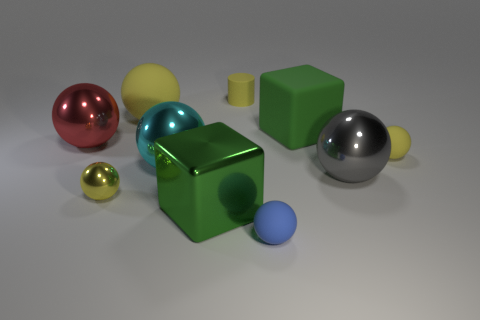Does the small cylinder have the same color as the tiny metallic thing?
Your answer should be compact. Yes. There is a rubber cube that is the same size as the cyan thing; what is its color?
Make the answer very short. Green. What number of shiny objects are big things or large blocks?
Your answer should be very brief. 4. What color is the big cube that is made of the same material as the gray ball?
Ensure brevity in your answer.  Green. There is a small object to the left of the yellow matte thing left of the small yellow matte cylinder; what is its material?
Give a very brief answer. Metal. What number of objects are either rubber things that are to the left of the green rubber block or big balls to the left of the small yellow shiny ball?
Your answer should be very brief. 4. There is a yellow rubber thing that is to the left of the tiny yellow object that is behind the large rubber thing that is on the left side of the big green metal thing; how big is it?
Offer a terse response. Large. Are there an equal number of big green metal things to the left of the large cyan ball and green shiny things?
Offer a terse response. No. Is there anything else that has the same shape as the large yellow thing?
Ensure brevity in your answer.  Yes. Is the shape of the small blue thing the same as the object that is to the left of the yellow metal object?
Offer a terse response. Yes. 